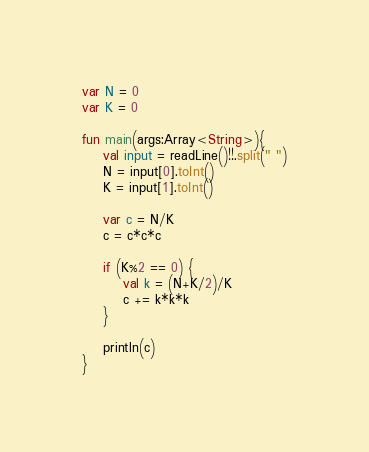<code> <loc_0><loc_0><loc_500><loc_500><_Kotlin_>var N = 0
var K = 0

fun main(args:Array<String>){
    val input = readLine()!!.split(" ")
    N = input[0].toInt()
    K = input[1].toInt()

    var c = N/K
    c = c*c*c

    if (K%2 == 0) {
        val k = (N+K/2)/K
        c += k*k*k
    }

    println(c)
}</code> 